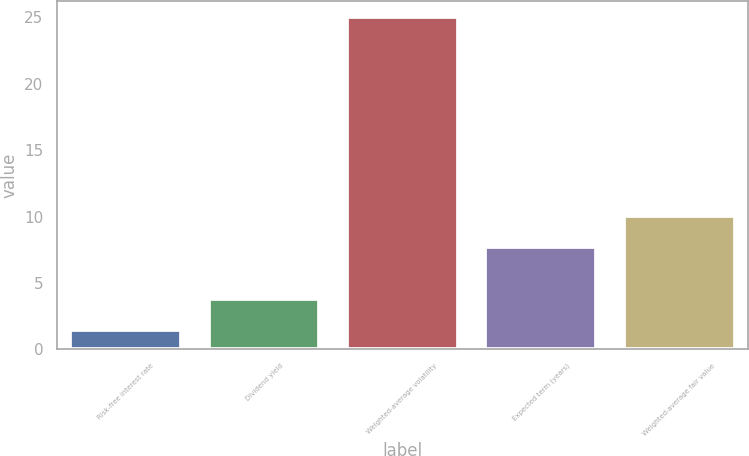Convert chart to OTSL. <chart><loc_0><loc_0><loc_500><loc_500><bar_chart><fcel>Risk-free interest rate<fcel>Dividend yield<fcel>Weighted-average volatility<fcel>Expected term (years)<fcel>Weighted-average fair value<nl><fcel>1.43<fcel>3.79<fcel>25.02<fcel>7.7<fcel>10.06<nl></chart> 